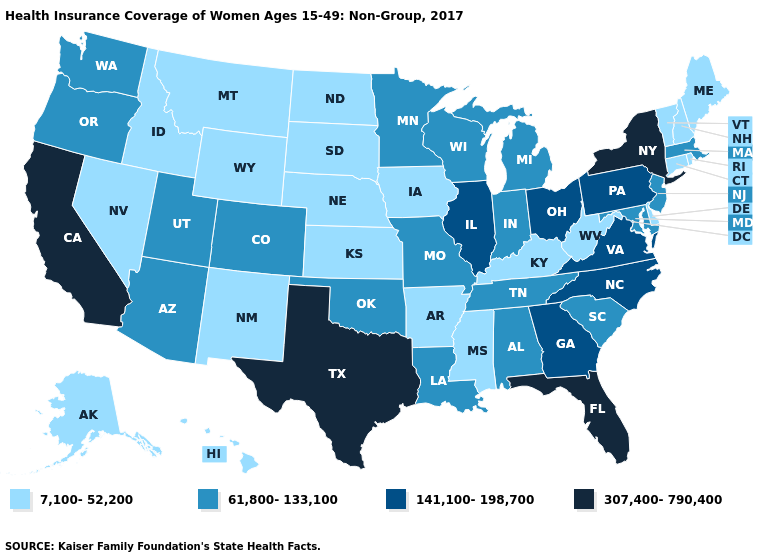Which states have the lowest value in the USA?
Keep it brief. Alaska, Arkansas, Connecticut, Delaware, Hawaii, Idaho, Iowa, Kansas, Kentucky, Maine, Mississippi, Montana, Nebraska, Nevada, New Hampshire, New Mexico, North Dakota, Rhode Island, South Dakota, Vermont, West Virginia, Wyoming. What is the value of Delaware?
Short answer required. 7,100-52,200. Among the states that border Texas , which have the lowest value?
Short answer required. Arkansas, New Mexico. What is the value of Wisconsin?
Concise answer only. 61,800-133,100. Does Colorado have the highest value in the USA?
Be succinct. No. Among the states that border Georgia , does Florida have the lowest value?
Answer briefly. No. What is the value of Washington?
Write a very short answer. 61,800-133,100. How many symbols are there in the legend?
Keep it brief. 4. Name the states that have a value in the range 7,100-52,200?
Give a very brief answer. Alaska, Arkansas, Connecticut, Delaware, Hawaii, Idaho, Iowa, Kansas, Kentucky, Maine, Mississippi, Montana, Nebraska, Nevada, New Hampshire, New Mexico, North Dakota, Rhode Island, South Dakota, Vermont, West Virginia, Wyoming. Among the states that border New York , does Massachusetts have the lowest value?
Be succinct. No. What is the value of Washington?
Answer briefly. 61,800-133,100. Which states hav the highest value in the MidWest?
Be succinct. Illinois, Ohio. What is the value of Florida?
Be succinct. 307,400-790,400. What is the highest value in the South ?
Quick response, please. 307,400-790,400. Name the states that have a value in the range 307,400-790,400?
Be succinct. California, Florida, New York, Texas. 